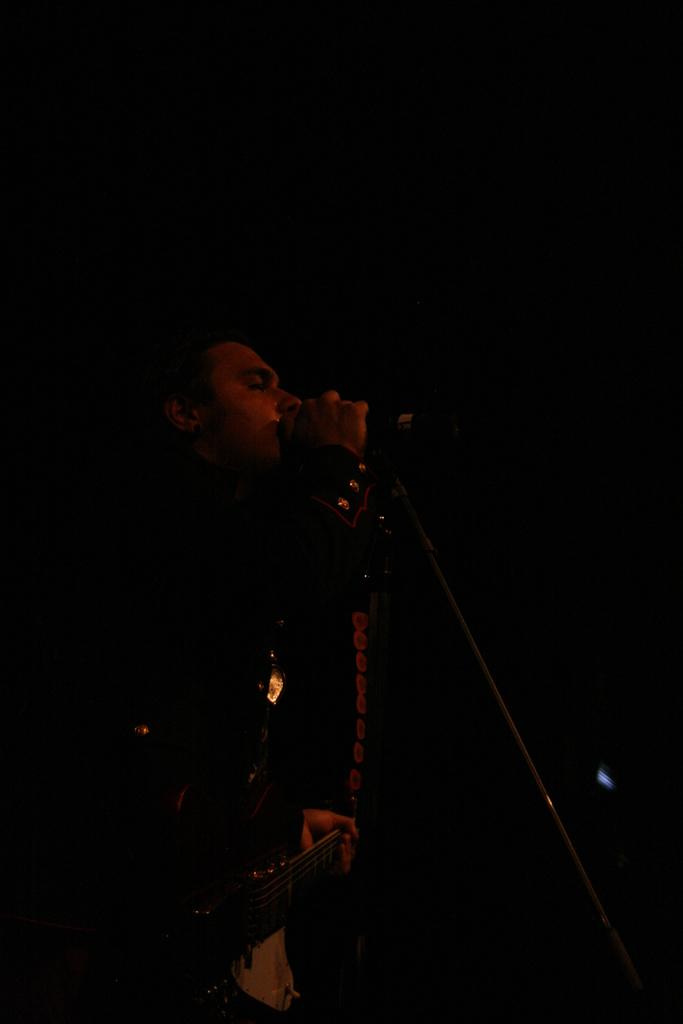Who is the main subject in the image? There is a person in the image. What is the person holding in the image? The person is holding a guitar. What is the person doing in the image? The person is singing. What object is the person standing in front of? The person is in front of a microphone. How many spiders are crawling on the guitar in the image? There are no spiders present in the image; the guitar is being held by the person who is singing. 